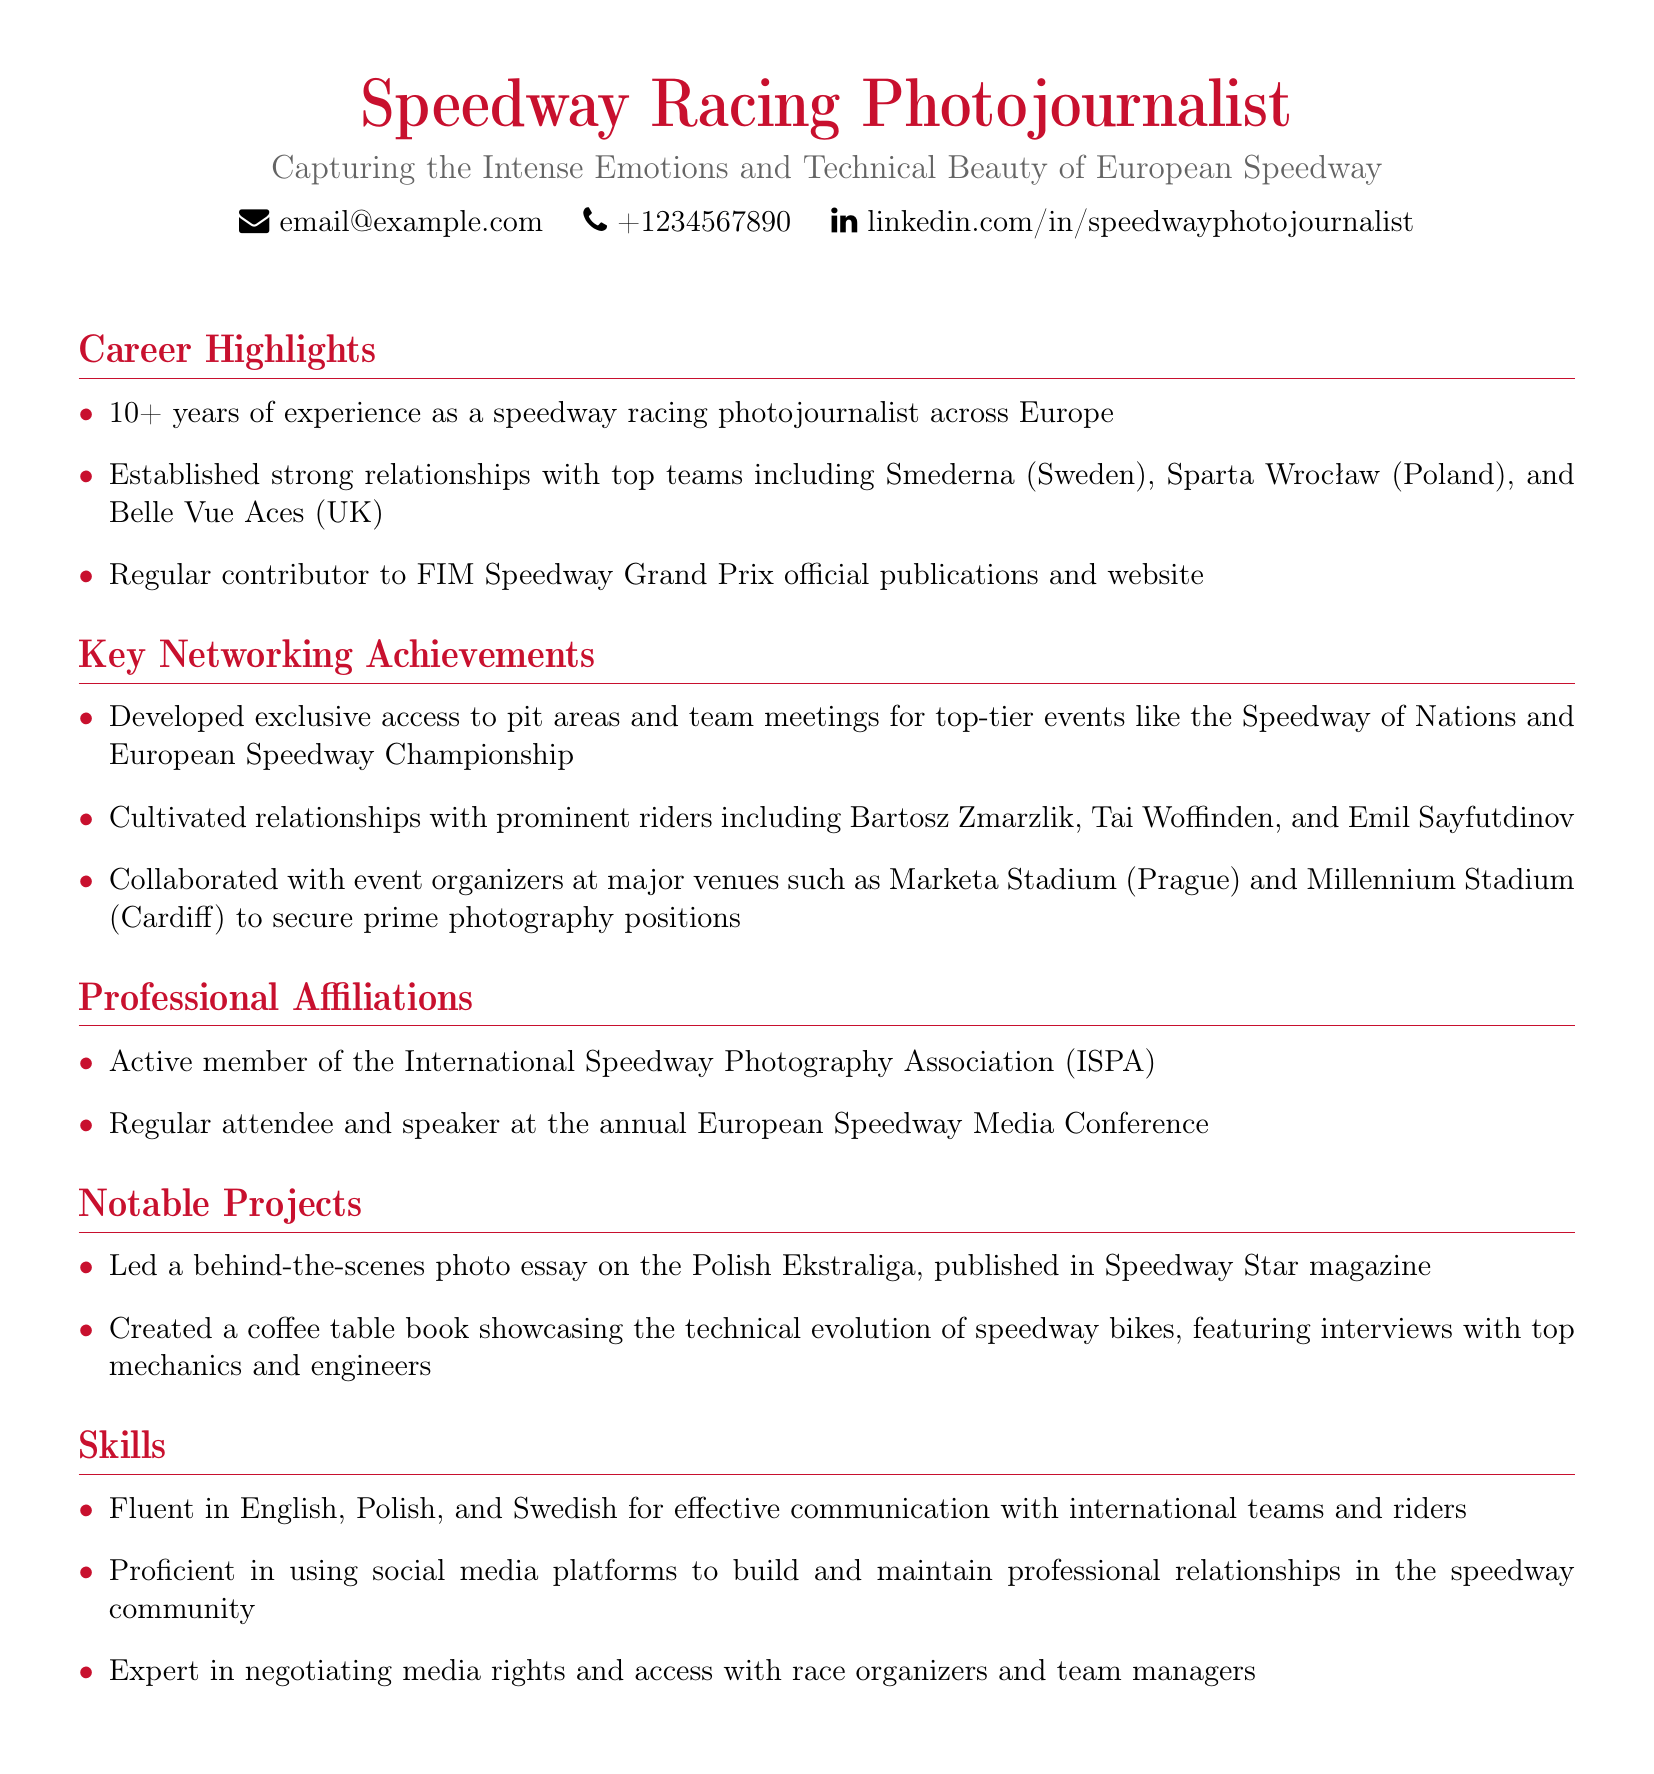what is the total years of experience mentioned? The total years of experience as a speedway racing photojournalist is highlighted in the Career Highlights section.
Answer: 10+ years which teams are mentioned in the established relationships? The teams that are established relationships are listed in the Career Highlights section.
Answer: Smederna, Sparta Wrocław, Belle Vue Aces what is the name of the coffee table book created? The notable project that showcases the technical evolution of speedway bikes is mentioned in the Notable Projects section.
Answer: Coffee table book showcasing the technical evolution of speedway bikes who are some of the prominent riders mentioned? The notable riders the photojournalist cultivated relationships with are listed in the Key Networking Achievements section.
Answer: Bartosz Zmarzlik, Tai Woffinden, Emil Sayfutdinov what organization is the photojournalist an active member of? The Professional Affiliations section lists the organization the photojournalist is affiliated with.
Answer: International Speedway Photography Association how many major venues are collaborated with for photography positions? The number of major venues is specified in the Key Networking Achievements section.
Answer: 2 major venues which languages is the photojournalist fluent in? The languages spoken fluently are mentioned in the Skills section.
Answer: English, Polish, Swedish what event is mentioned for exclusive access development? The event where exclusive access was developed is included in the Key Networking Achievements section.
Answer: Speedway of Nations what type of media rights does the photojournalist negotiate? The type of media rights negotiated is outlined in the Skills section.
Answer: Media rights and access 